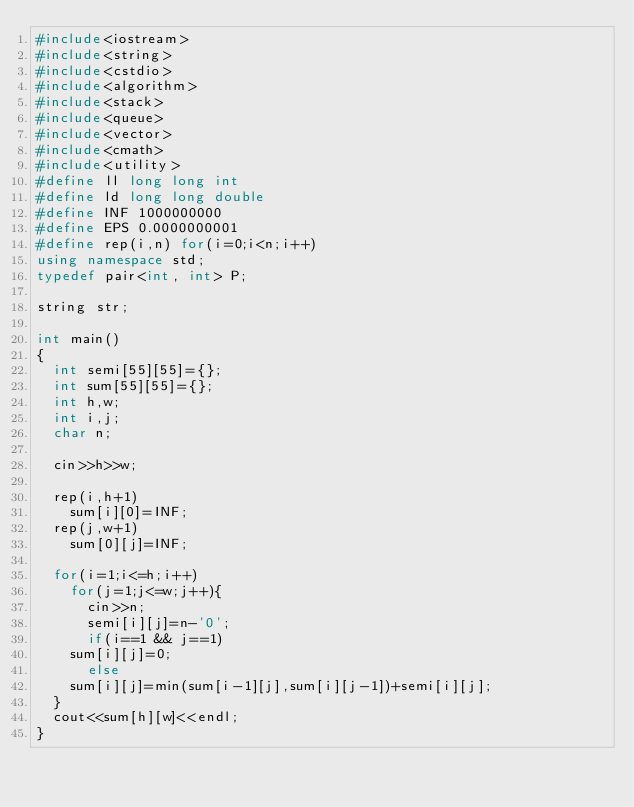Convert code to text. <code><loc_0><loc_0><loc_500><loc_500><_C++_>#include<iostream>
#include<string>
#include<cstdio>
#include<algorithm>
#include<stack>
#include<queue>
#include<vector>
#include<cmath>
#include<utility>
#define ll long long int
#define ld long long double
#define INF 1000000000
#define EPS 0.0000000001
#define rep(i,n) for(i=0;i<n;i++)
using namespace std;
typedef pair<int, int> P;

string str;

int main()
{
  int semi[55][55]={};
  int sum[55][55]={};
  int h,w;
  int i,j;
  char n;

  cin>>h>>w;

  rep(i,h+1)
    sum[i][0]=INF;
  rep(j,w+1)
    sum[0][j]=INF;

  for(i=1;i<=h;i++)
    for(j=1;j<=w;j++){
      cin>>n;
      semi[i][j]=n-'0';
      if(i==1 && j==1)
	sum[i][j]=0;
      else 
	sum[i][j]=min(sum[i-1][j],sum[i][j-1])+semi[i][j];
  }
  cout<<sum[h][w]<<endl;
}</code> 